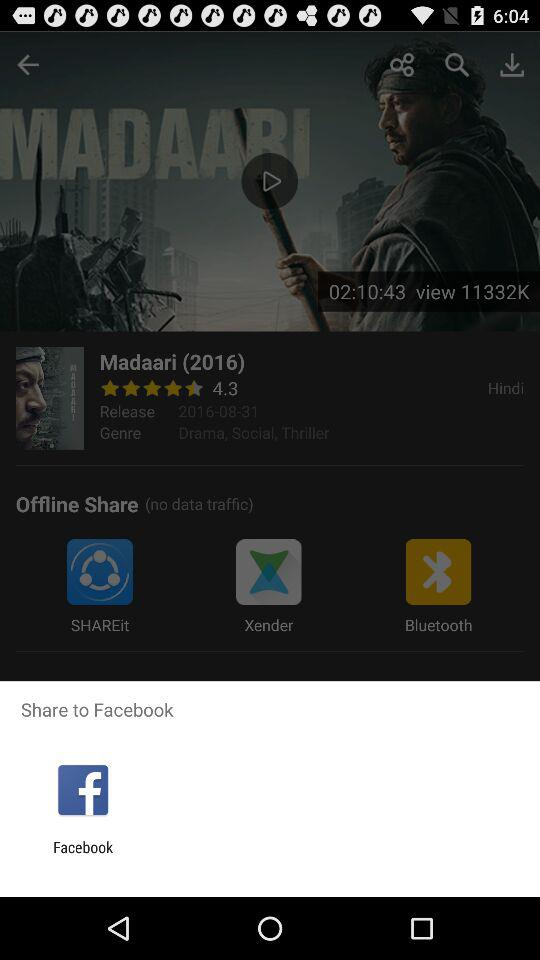To what app can we share? You can share to "Facebook". 